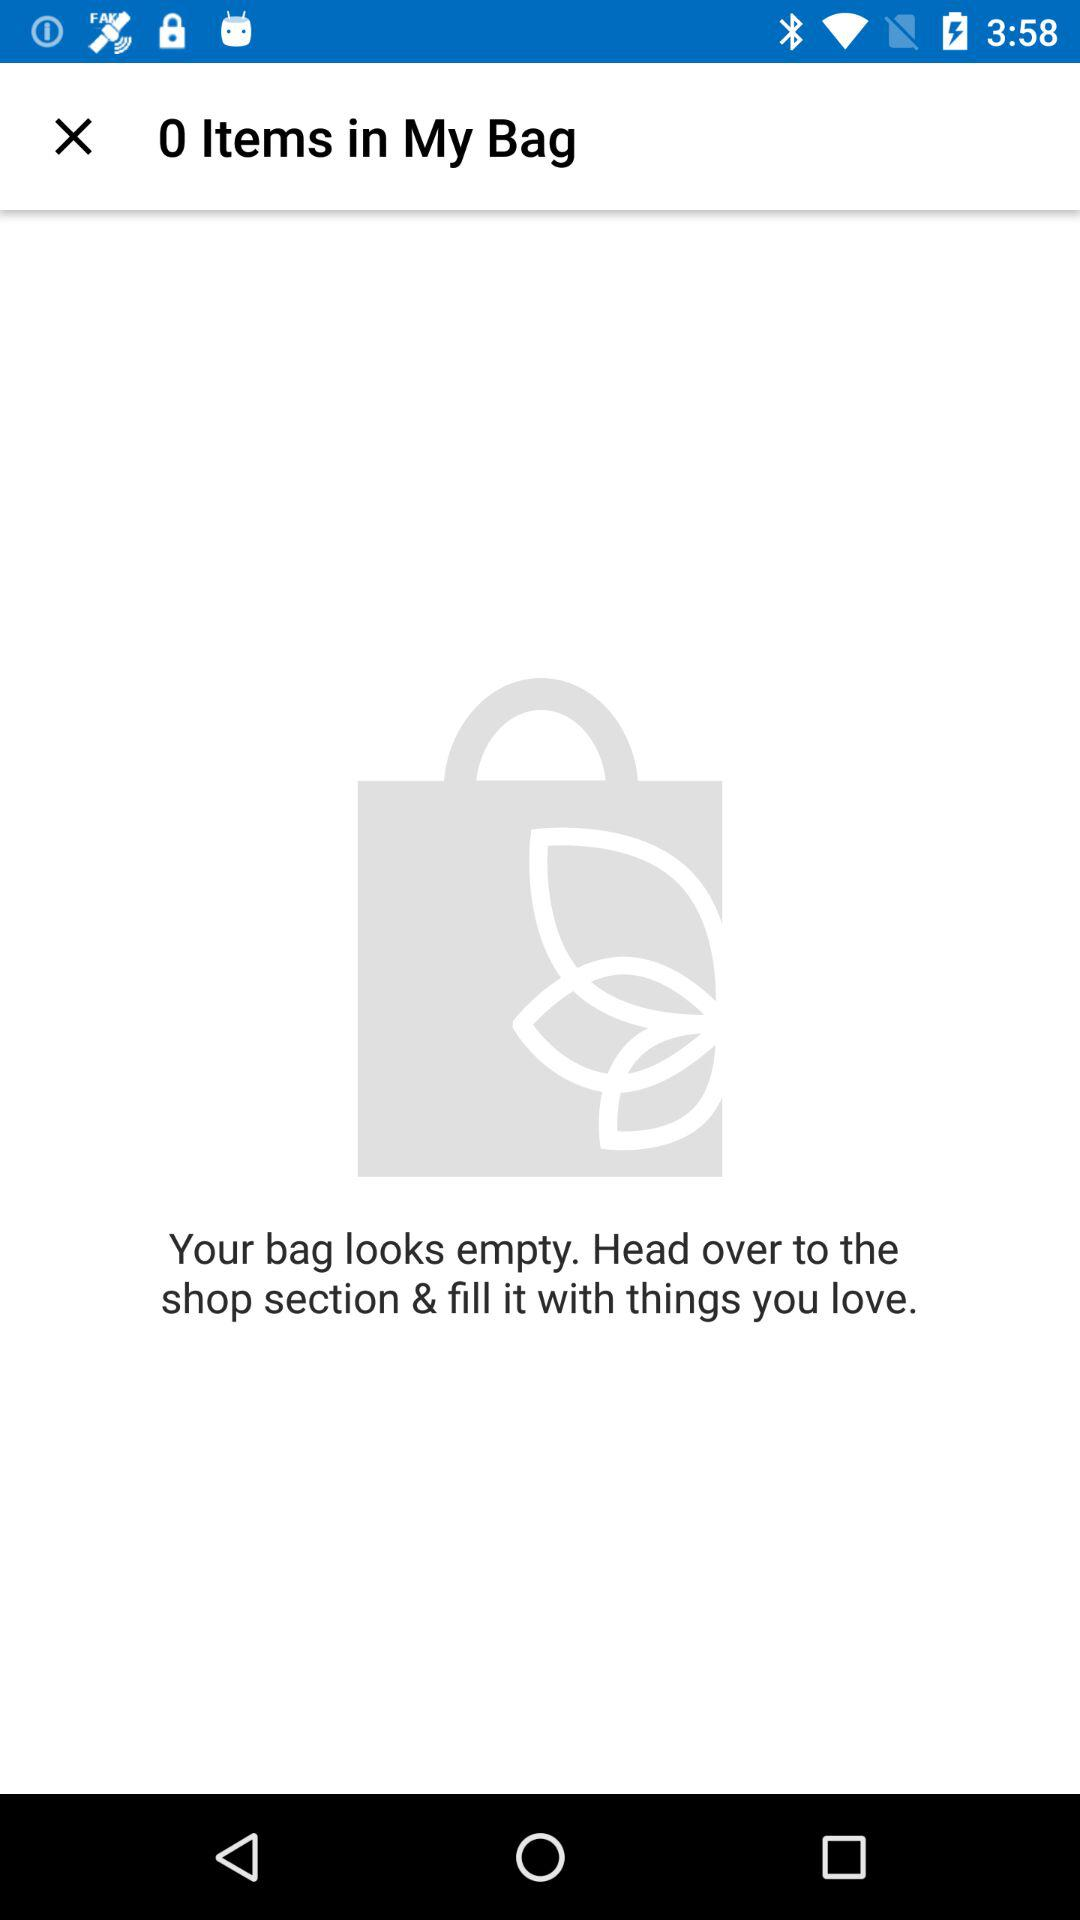How many items are in the user's bag?
Answer the question using a single word or phrase. 0 